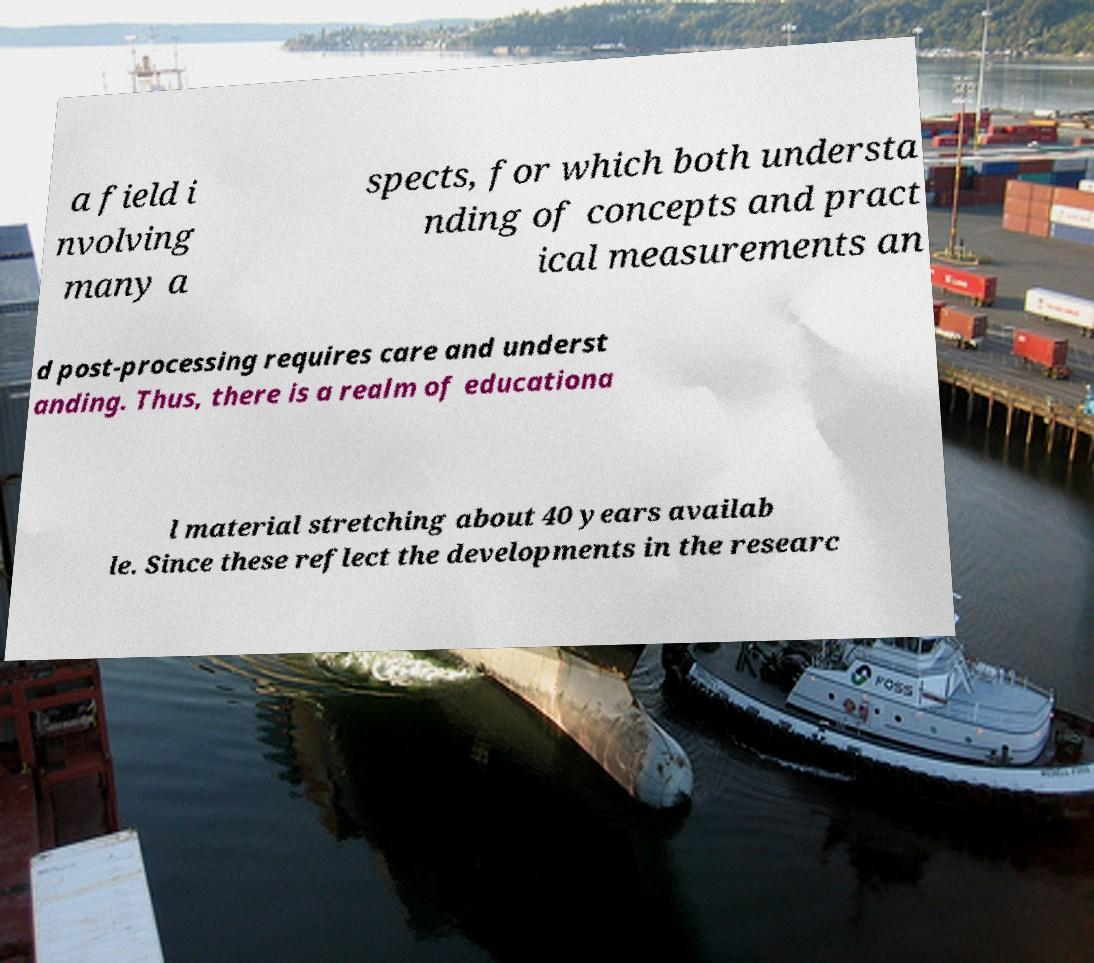I need the written content from this picture converted into text. Can you do that? a field i nvolving many a spects, for which both understa nding of concepts and pract ical measurements an d post-processing requires care and underst anding. Thus, there is a realm of educationa l material stretching about 40 years availab le. Since these reflect the developments in the researc 